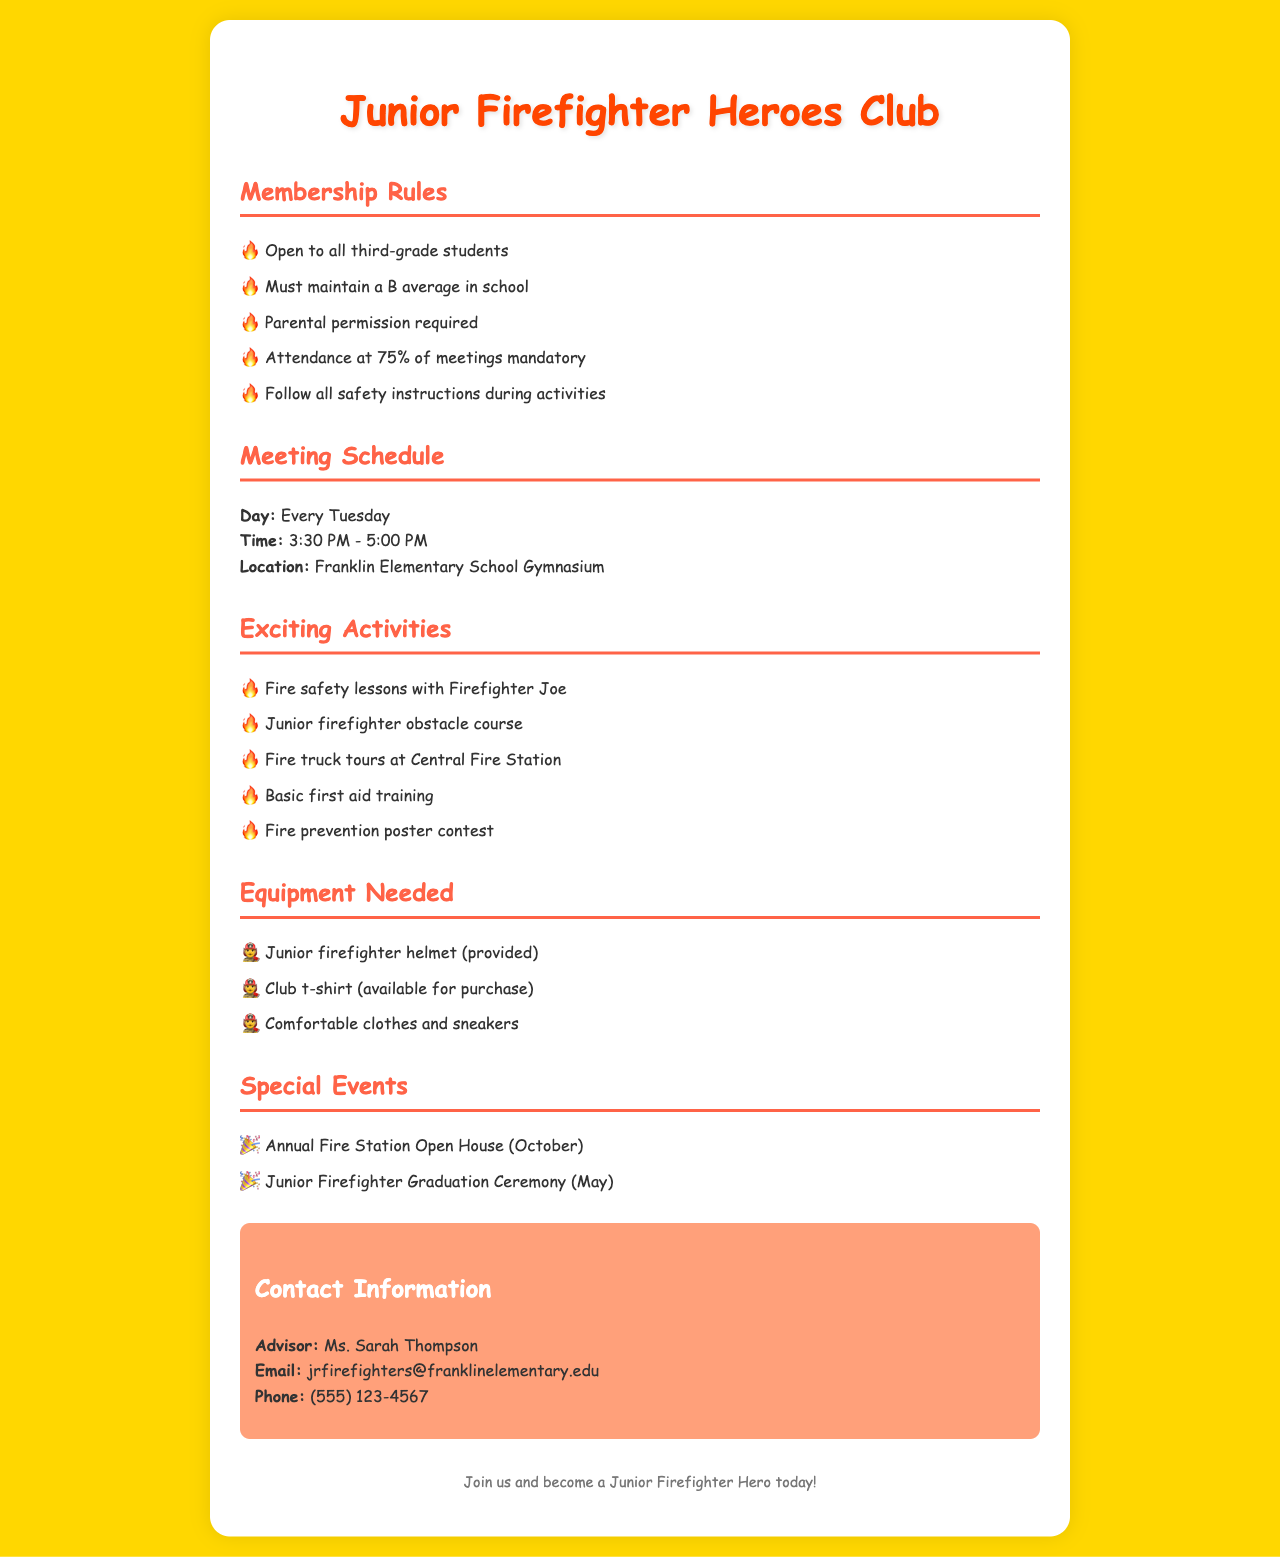What are the membership requirements? The membership requirements for the club include being a third-grade student, maintaining a B average in school, parental permission, attendance at 75% of meetings, and following safety instructions during activities.
Answer: Open to all third-grade students When do the meetings take place? The document specifies the day, time, and location of the meetings for the club.
Answer: Every Tuesday Who is the advisor for the Junior Firefighter Heroes Club? The document provides the name of the club advisor.
Answer: Ms. Sarah Thompson What type of activities are included in the club? The document lists several exciting activities that members will participate in during the club meetings.
Answer: Fire safety lessons with Firefighter Joe What equipment is provided to junior firefighters? The document mentions specific equipment that is provided or needed for club members.
Answer: Junior firefighter helmet (provided) 